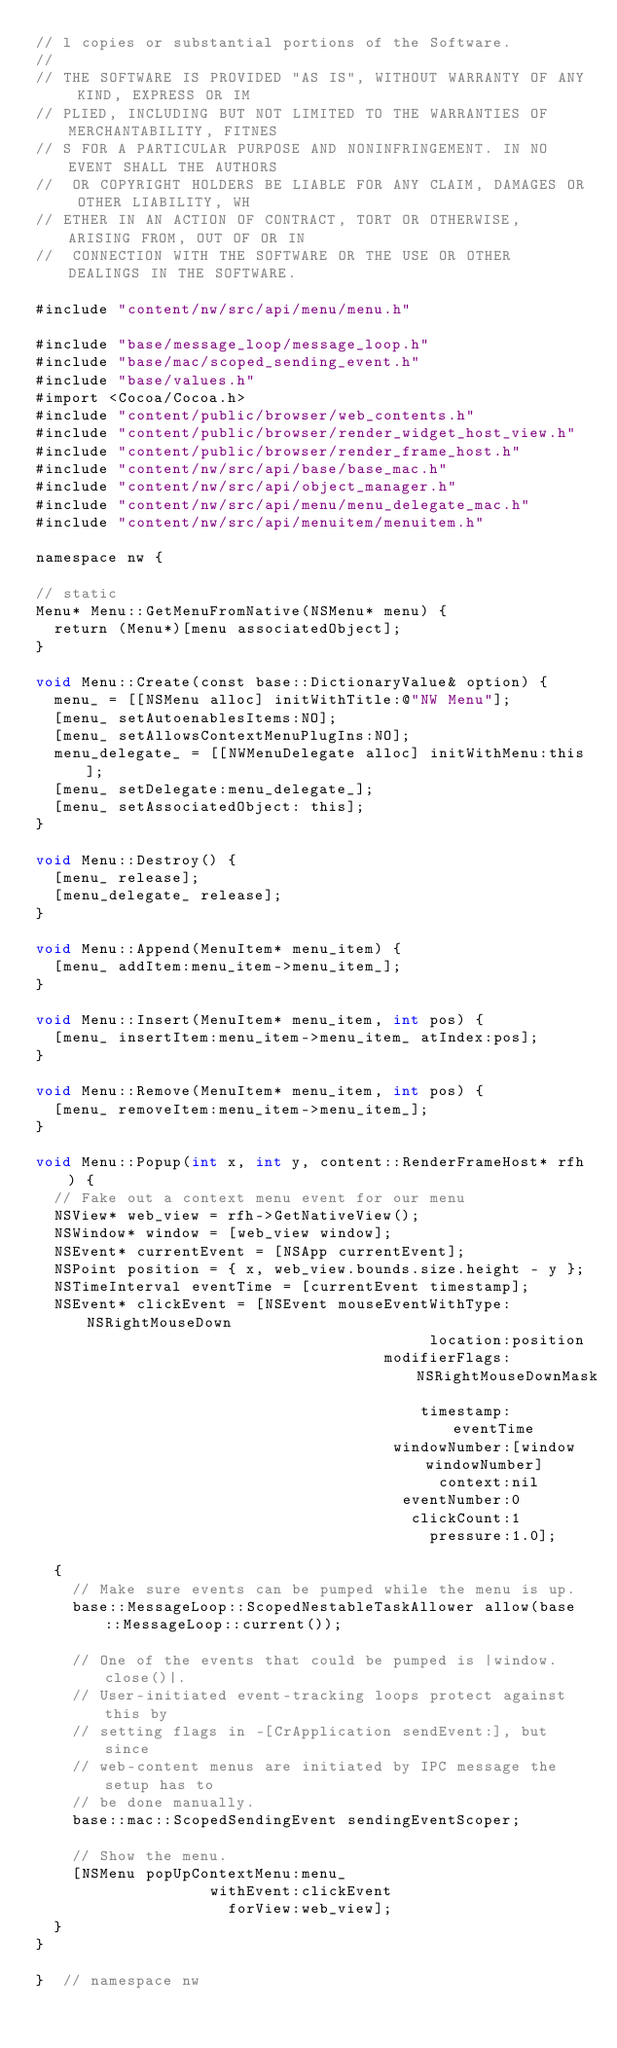<code> <loc_0><loc_0><loc_500><loc_500><_ObjectiveC_>// l copies or substantial portions of the Software.
//
// THE SOFTWARE IS PROVIDED "AS IS", WITHOUT WARRANTY OF ANY KIND, EXPRESS OR IM
// PLIED, INCLUDING BUT NOT LIMITED TO THE WARRANTIES OF MERCHANTABILITY, FITNES
// S FOR A PARTICULAR PURPOSE AND NONINFRINGEMENT. IN NO EVENT SHALL THE AUTHORS
//  OR COPYRIGHT HOLDERS BE LIABLE FOR ANY CLAIM, DAMAGES OR OTHER LIABILITY, WH
// ETHER IN AN ACTION OF CONTRACT, TORT OR OTHERWISE, ARISING FROM, OUT OF OR IN
//  CONNECTION WITH THE SOFTWARE OR THE USE OR OTHER DEALINGS IN THE SOFTWARE.

#include "content/nw/src/api/menu/menu.h"

#include "base/message_loop/message_loop.h"
#include "base/mac/scoped_sending_event.h"
#include "base/values.h"
#import <Cocoa/Cocoa.h>
#include "content/public/browser/web_contents.h"
#include "content/public/browser/render_widget_host_view.h"
#include "content/public/browser/render_frame_host.h"
#include "content/nw/src/api/base/base_mac.h"
#include "content/nw/src/api/object_manager.h"
#include "content/nw/src/api/menu/menu_delegate_mac.h"
#include "content/nw/src/api/menuitem/menuitem.h"

namespace nw {

// static
Menu* Menu::GetMenuFromNative(NSMenu* menu) {
  return (Menu*)[menu associatedObject];
}

void Menu::Create(const base::DictionaryValue& option) {
  menu_ = [[NSMenu alloc] initWithTitle:@"NW Menu"];
  [menu_ setAutoenablesItems:NO];
  [menu_ setAllowsContextMenuPlugIns:NO];
  menu_delegate_ = [[NWMenuDelegate alloc] initWithMenu:this];
  [menu_ setDelegate:menu_delegate_];
  [menu_ setAssociatedObject: this];
}

void Menu::Destroy() {
  [menu_ release];
  [menu_delegate_ release];
}

void Menu::Append(MenuItem* menu_item) {
  [menu_ addItem:menu_item->menu_item_];
}

void Menu::Insert(MenuItem* menu_item, int pos) {
  [menu_ insertItem:menu_item->menu_item_ atIndex:pos];
}

void Menu::Remove(MenuItem* menu_item, int pos) {
  [menu_ removeItem:menu_item->menu_item_];
}

void Menu::Popup(int x, int y, content::RenderFrameHost* rfh) {
  // Fake out a context menu event for our menu
  NSView* web_view = rfh->GetNativeView();
  NSWindow* window = [web_view window];
  NSEvent* currentEvent = [NSApp currentEvent];
  NSPoint position = { x, web_view.bounds.size.height - y };
  NSTimeInterval eventTime = [currentEvent timestamp];
  NSEvent* clickEvent = [NSEvent mouseEventWithType:NSRightMouseDown
                                           location:position
                                      modifierFlags:NSRightMouseDownMask
                                          timestamp:eventTime
                                       windowNumber:[window windowNumber]
                                            context:nil
                                        eventNumber:0
                                         clickCount:1
                                           pressure:1.0];

  {
    // Make sure events can be pumped while the menu is up.
    base::MessageLoop::ScopedNestableTaskAllower allow(base::MessageLoop::current());

    // One of the events that could be pumped is |window.close()|.
    // User-initiated event-tracking loops protect against this by
    // setting flags in -[CrApplication sendEvent:], but since
    // web-content menus are initiated by IPC message the setup has to
    // be done manually.
    base::mac::ScopedSendingEvent sendingEventScoper;

    // Show the menu.
    [NSMenu popUpContextMenu:menu_
                   withEvent:clickEvent
                     forView:web_view];
  }
}

}  // namespace nw
</code> 